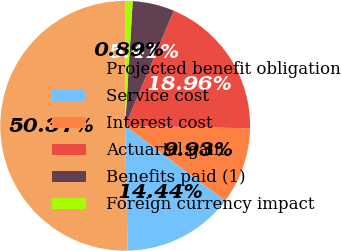<chart> <loc_0><loc_0><loc_500><loc_500><pie_chart><fcel>Projected benefit obligation<fcel>Service cost<fcel>Interest cost<fcel>Actuarial gain<fcel>Benefits paid (1)<fcel>Foreign currency impact<nl><fcel>50.37%<fcel>14.44%<fcel>9.93%<fcel>18.96%<fcel>5.41%<fcel>0.89%<nl></chart> 